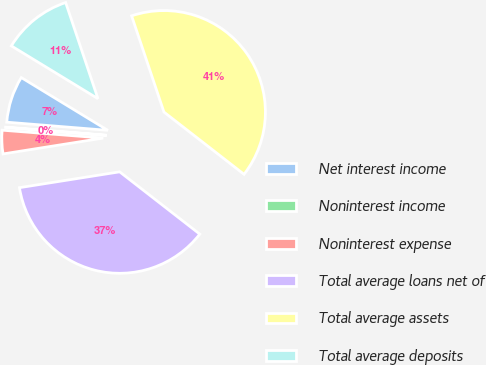<chart> <loc_0><loc_0><loc_500><loc_500><pie_chart><fcel>Net interest income<fcel>Noninterest income<fcel>Noninterest expense<fcel>Total average loans net of<fcel>Total average assets<fcel>Total average deposits<nl><fcel>7.43%<fcel>0.04%<fcel>3.74%<fcel>36.99%<fcel>40.68%<fcel>11.13%<nl></chart> 